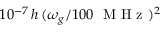Convert formula to latex. <formula><loc_0><loc_0><loc_500><loc_500>1 0 ^ { - 7 } \, h \, ( \omega _ { g } / 1 0 0 M H z ) ^ { 2 }</formula> 